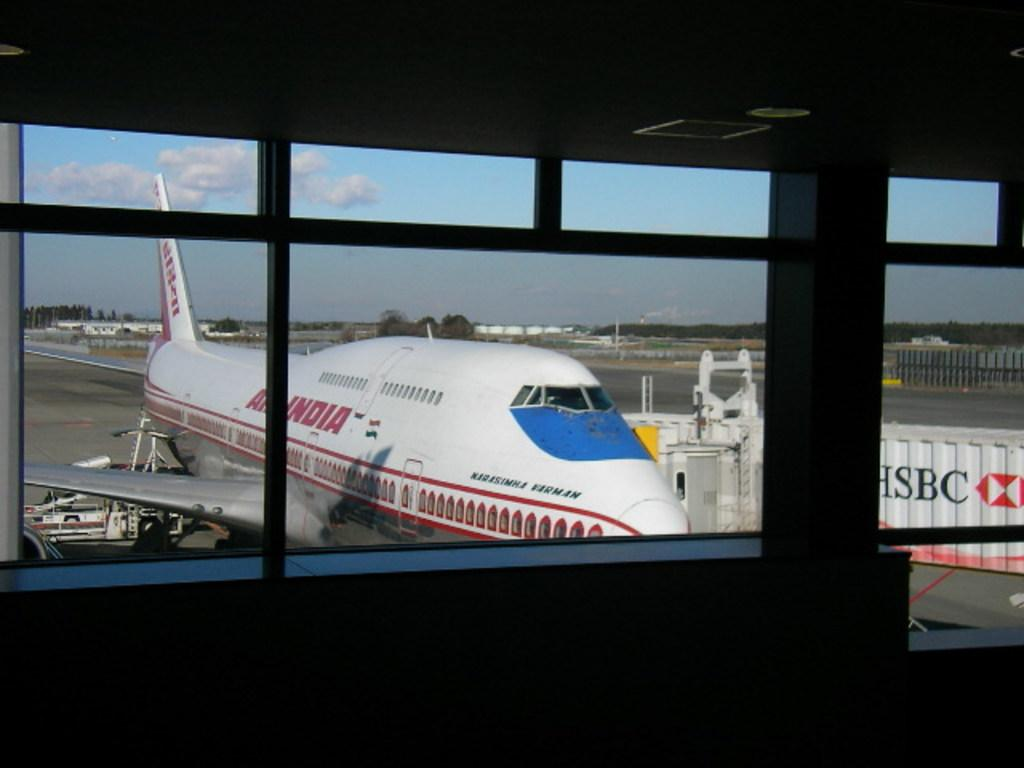Provide a one-sentence caption for the provided image. A white and red plane has India painted on the side. 